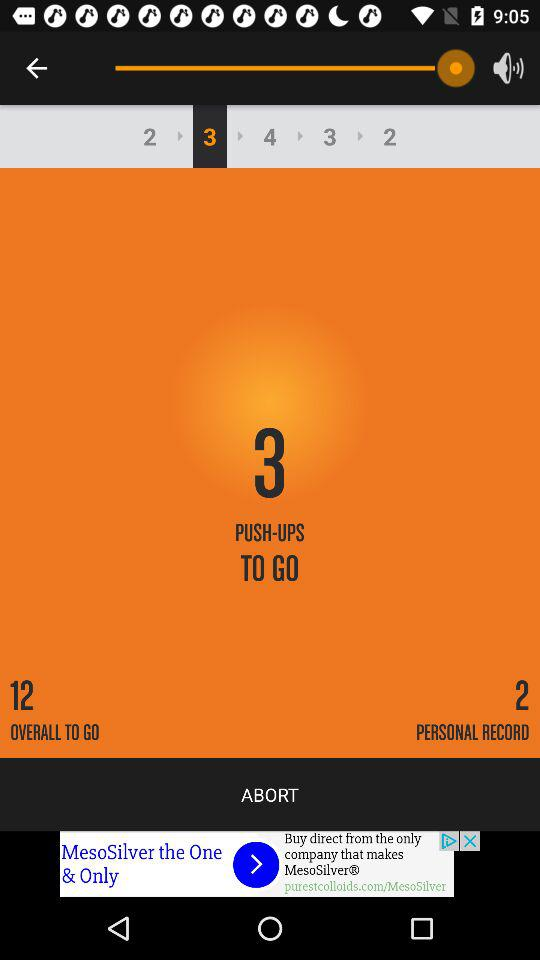What's the number of personal records? The number of personal records is 2. 